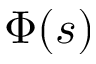Convert formula to latex. <formula><loc_0><loc_0><loc_500><loc_500>\Phi ( s )</formula> 